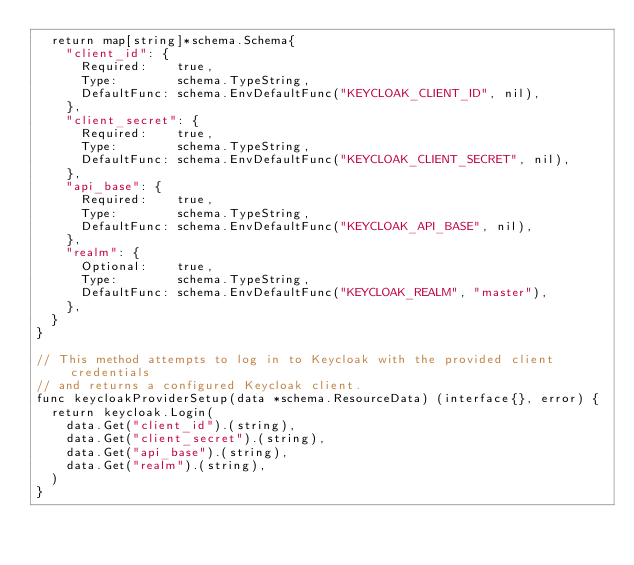<code> <loc_0><loc_0><loc_500><loc_500><_Go_>	return map[string]*schema.Schema{
		"client_id": {
			Required:    true,
			Type:        schema.TypeString,
			DefaultFunc: schema.EnvDefaultFunc("KEYCLOAK_CLIENT_ID", nil),
		},
		"client_secret": {
			Required:    true,
			Type:        schema.TypeString,
			DefaultFunc: schema.EnvDefaultFunc("KEYCLOAK_CLIENT_SECRET", nil),
		},
		"api_base": {
			Required:    true,
			Type:        schema.TypeString,
			DefaultFunc: schema.EnvDefaultFunc("KEYCLOAK_API_BASE", nil),
		},
		"realm": {
			Optional:    true,
			Type:        schema.TypeString,
			DefaultFunc: schema.EnvDefaultFunc("KEYCLOAK_REALM", "master"),
		},
	}
}

// This method attempts to log in to Keycloak with the provided client credentials
// and returns a configured Keycloak client.
func keycloakProviderSetup(data *schema.ResourceData) (interface{}, error) {
	return keycloak.Login(
		data.Get("client_id").(string),
		data.Get("client_secret").(string),
		data.Get("api_base").(string),
		data.Get("realm").(string),
	)
}
</code> 